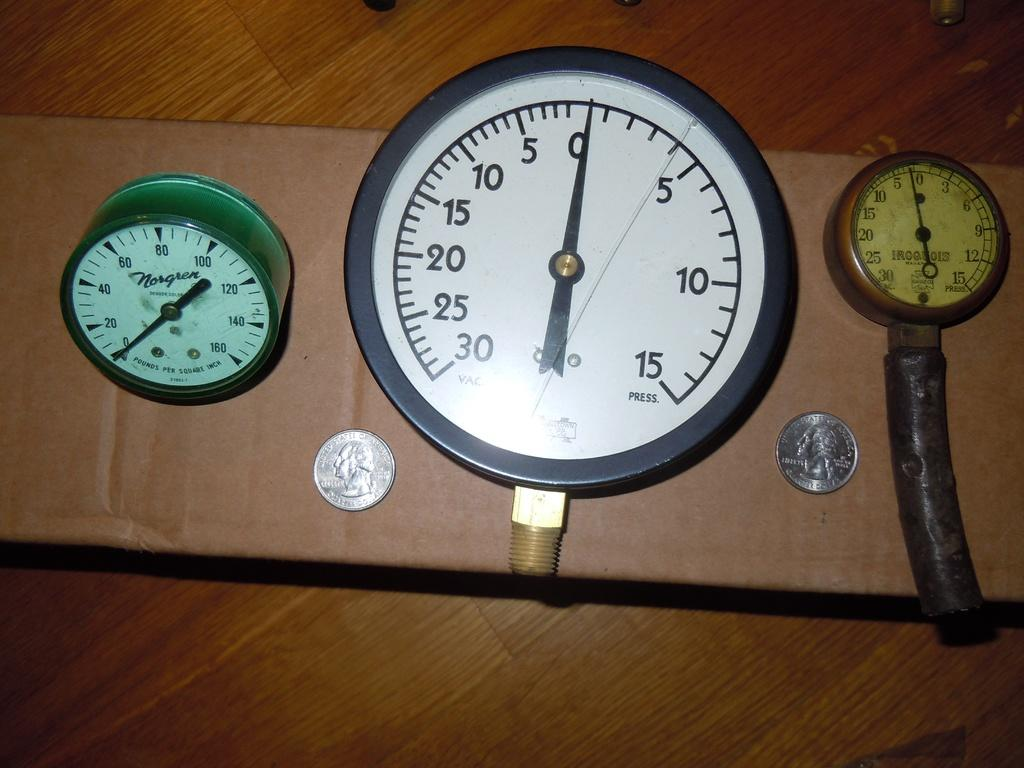<image>
Create a compact narrative representing the image presented. Three pressure gauges sit next to two quarters and one of the gauges is a Norgren model. 